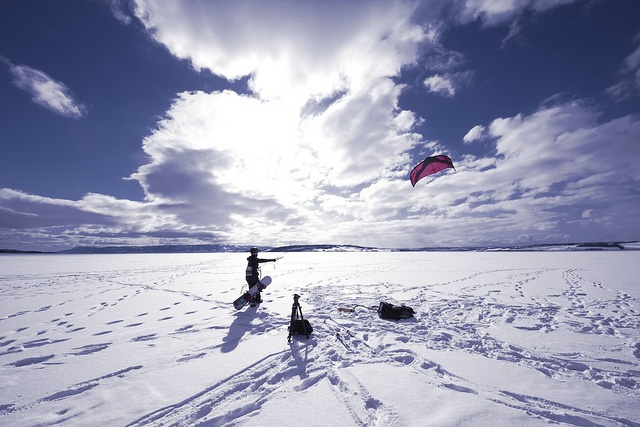Describe the objects in this image and their specific colors. I can see kite in navy, black, and purple tones, people in navy, black, white, gray, and darkgray tones, backpack in navy, black, gray, and darkgray tones, snowboard in navy, black, purple, and gray tones, and backpack in navy, black, gray, darkgray, and lavender tones in this image. 